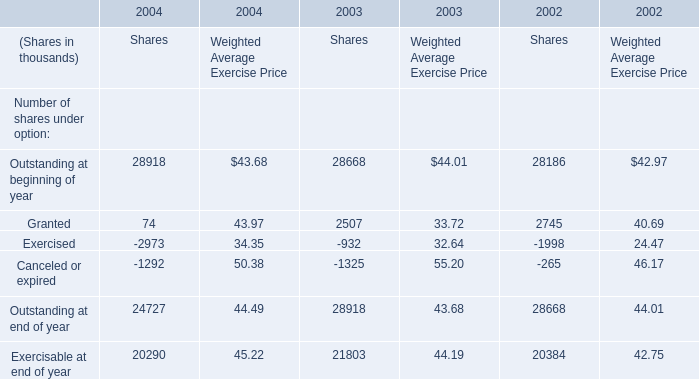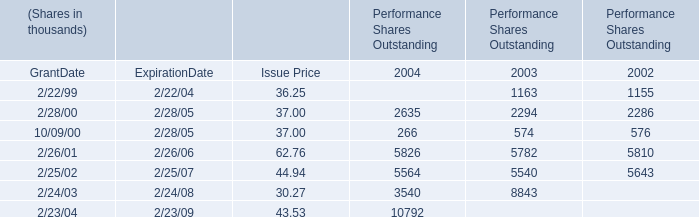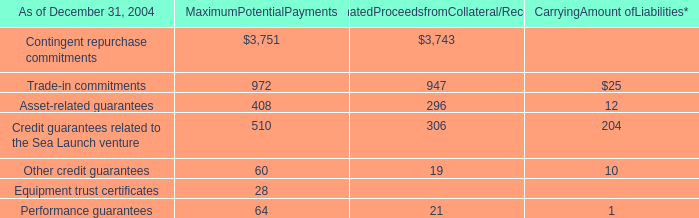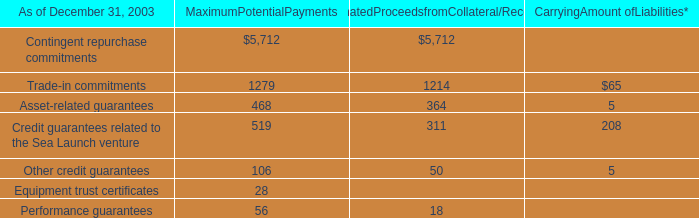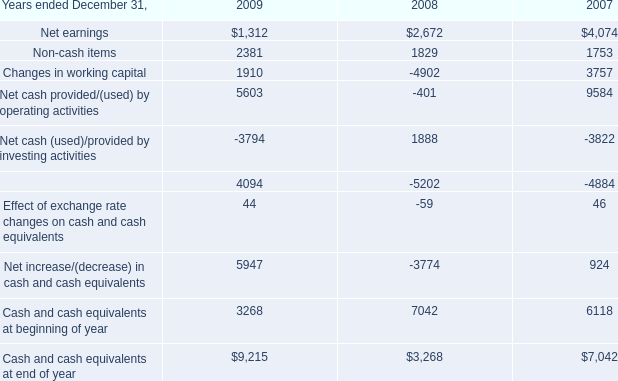What is the sum of 2/28/00 of Performance Shares Outstanding 2002, and Cash and cash equivalents at end of year of 2008 ? 
Computations: (2286.0 + 3268.0)
Answer: 5554.0. 